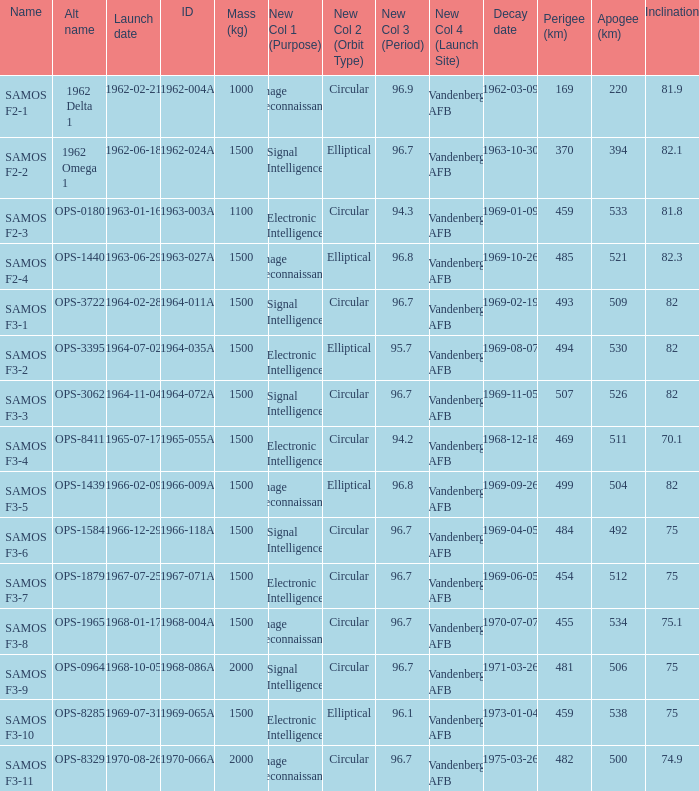What was the maximum perigee on 1969-01-09? 459.0. 